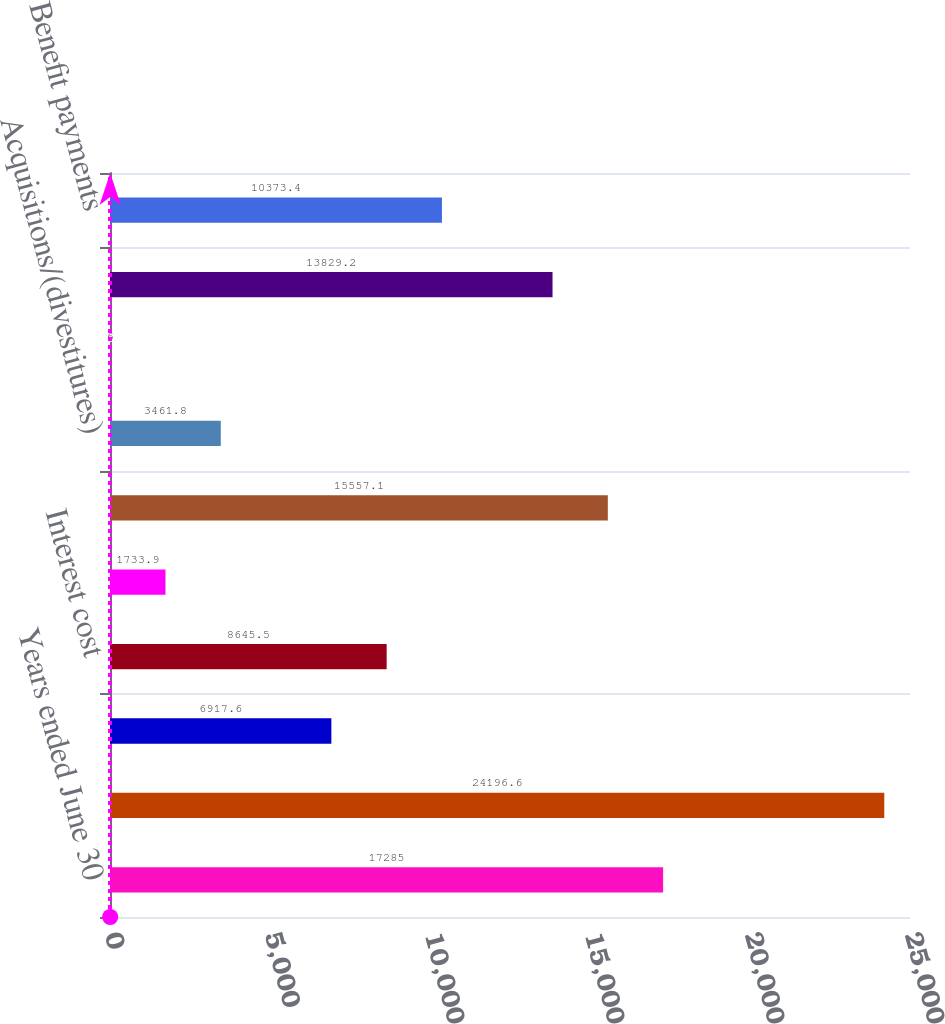Convert chart to OTSL. <chart><loc_0><loc_0><loc_500><loc_500><bar_chart><fcel>Years ended June 30<fcel>Benefit obligation at<fcel>Service cost<fcel>Interest cost<fcel>Participants' contributions<fcel>Net actuarial loss/(gain)<fcel>Acquisitions/(divestitures)<fcel>Special termination benefits<fcel>Currency translation and other<fcel>Benefit payments<nl><fcel>17285<fcel>24196.6<fcel>6917.6<fcel>8645.5<fcel>1733.9<fcel>15557.1<fcel>3461.8<fcel>6<fcel>13829.2<fcel>10373.4<nl></chart> 